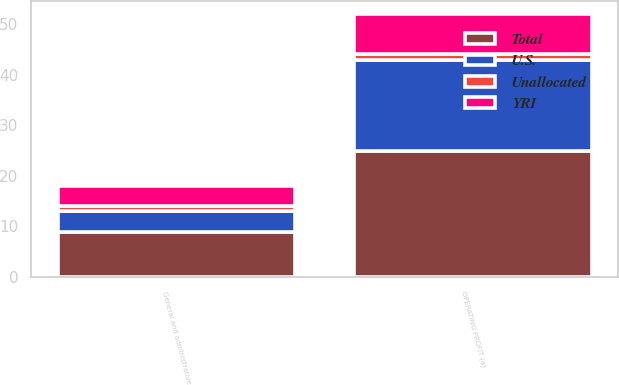Convert chart to OTSL. <chart><loc_0><loc_0><loc_500><loc_500><stacked_bar_chart><ecel><fcel>General and administrative<fcel>OPERATING PROFIT (a)<nl><fcel>U.S.<fcel>4<fcel>18<nl><fcel>YRI<fcel>4<fcel>8<nl><fcel>Unallocated<fcel>1<fcel>1<nl><fcel>Total<fcel>9<fcel>25<nl></chart> 